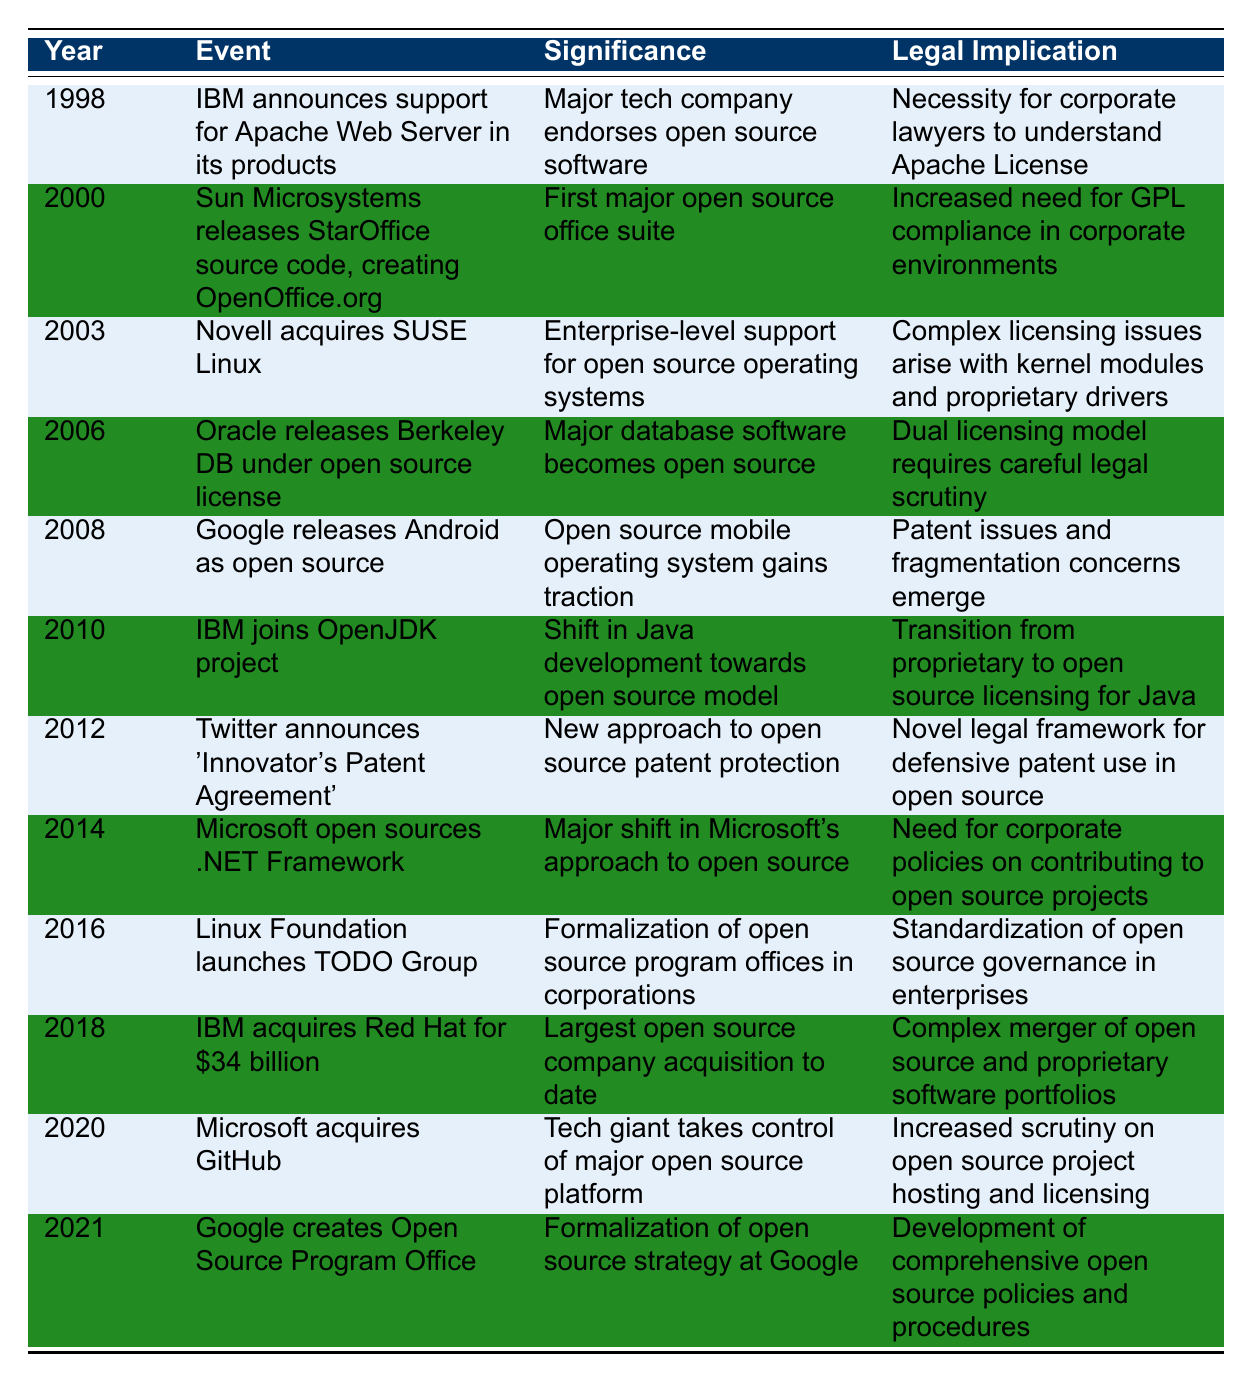What event occurred in 2000? The table indicates that in 2000, Sun Microsystems released the StarOffice source code, creating OpenOffice.org.
Answer: Sun Microsystems releases StarOffice source code, creating OpenOffice.org What is the significance of IBM acquiring Red Hat in 2018? According to the table, the significance of IBM acquiring Red Hat is that it was the largest open source company acquisition to date.
Answer: Largest open source company acquisition to date Did Microsoft open source the .NET Framework before acquiring GitHub? Yes, the table shows that Microsoft open sourced the .NET Framework in 2014, which is before acquiring GitHub in 2020.
Answer: Yes How many events are related to the introduction of open source strategies by major technology companies? By inspecting the table, there are four events that mention open source strategies: IBM supporting Apache in 1998, Twitter's Patent Agreement in 2012, Microsoft open sourcing .NET in 2014, and Google creating an Open Source Program Office in 2021. Thus, the count is 4.
Answer: 4 What legal implication was associated with Oracle releasing Berkeley DB in 2006? The table states that the legal implication of Oracle releasing Berkeley DB was that the dual licensing model requires careful legal scrutiny.
Answer: Dual licensing model requires careful legal scrutiny What year saw the launch of the TODO Group by the Linux Foundation? The table specifies that the TODO Group was launched by the Linux Foundation in 2016.
Answer: 2016 Is it true that IBM was the first major tech company to endorse open source software? Yes, the data suggests that in 1998, IBM announced support for the Apache Web Server in its products, which aligns with it being a significant endorsement of open source software.
Answer: Yes Which two events in the table involve major acquisitions and what were the years? In 2018, IBM acquired Red Hat, and in 2020, Microsoft acquired GitHub. Thus, the two events related to major acquisitions are in the years 2018 and 2020.
Answer: 2018 and 2020 What are the legal implications arising from Novell acquiring SUSE Linux in 2003? The table outlines that the legal implication arising from Novell acquiring SUSE Linux is that complex licensing issues arise with kernel modules and proprietary drivers.
Answer: Complex licensing issues arise with kernel modules and proprietary drivers 